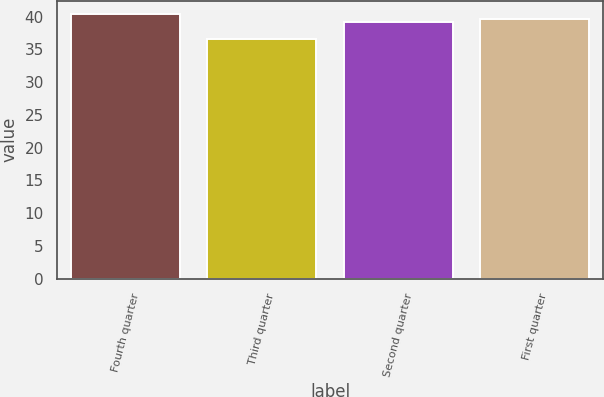Convert chart. <chart><loc_0><loc_0><loc_500><loc_500><bar_chart><fcel>Fourth quarter<fcel>Third quarter<fcel>Second quarter<fcel>First quarter<nl><fcel>40.43<fcel>36.56<fcel>39.12<fcel>39.61<nl></chart> 